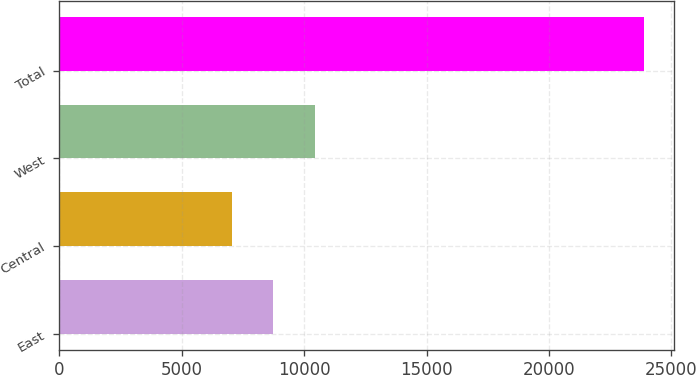Convert chart to OTSL. <chart><loc_0><loc_0><loc_500><loc_500><bar_chart><fcel>East<fcel>Central<fcel>West<fcel>Total<nl><fcel>8740.3<fcel>7056<fcel>10424.6<fcel>23899<nl></chart> 